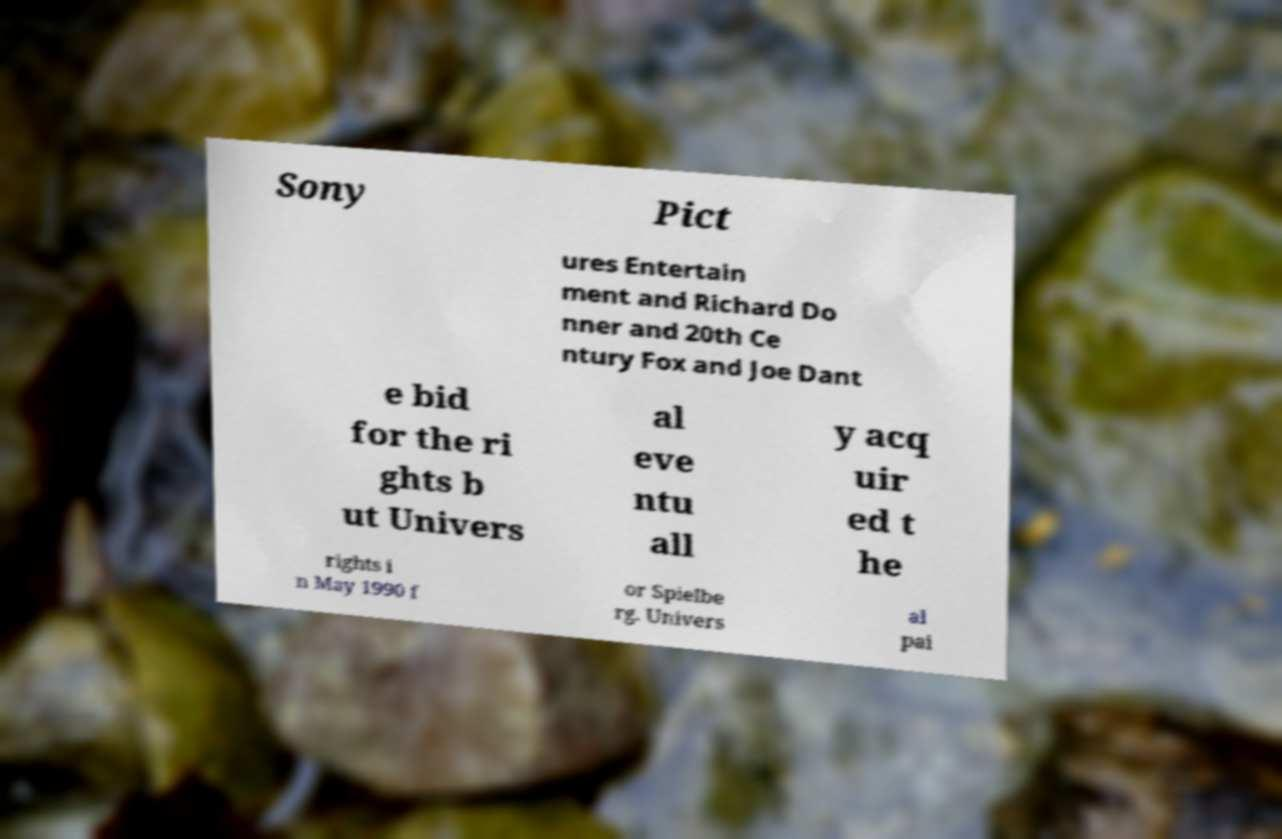Can you read and provide the text displayed in the image?This photo seems to have some interesting text. Can you extract and type it out for me? Sony Pict ures Entertain ment and Richard Do nner and 20th Ce ntury Fox and Joe Dant e bid for the ri ghts b ut Univers al eve ntu all y acq uir ed t he rights i n May 1990 f or Spielbe rg. Univers al pai 